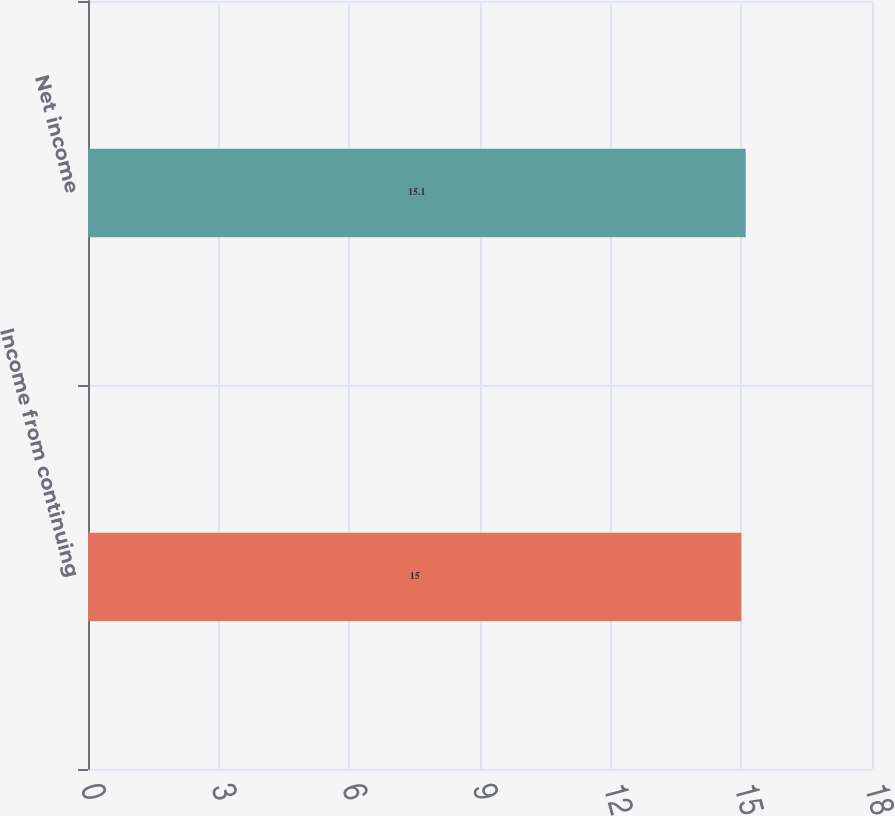Convert chart to OTSL. <chart><loc_0><loc_0><loc_500><loc_500><bar_chart><fcel>Income from continuing<fcel>Net income<nl><fcel>15<fcel>15.1<nl></chart> 